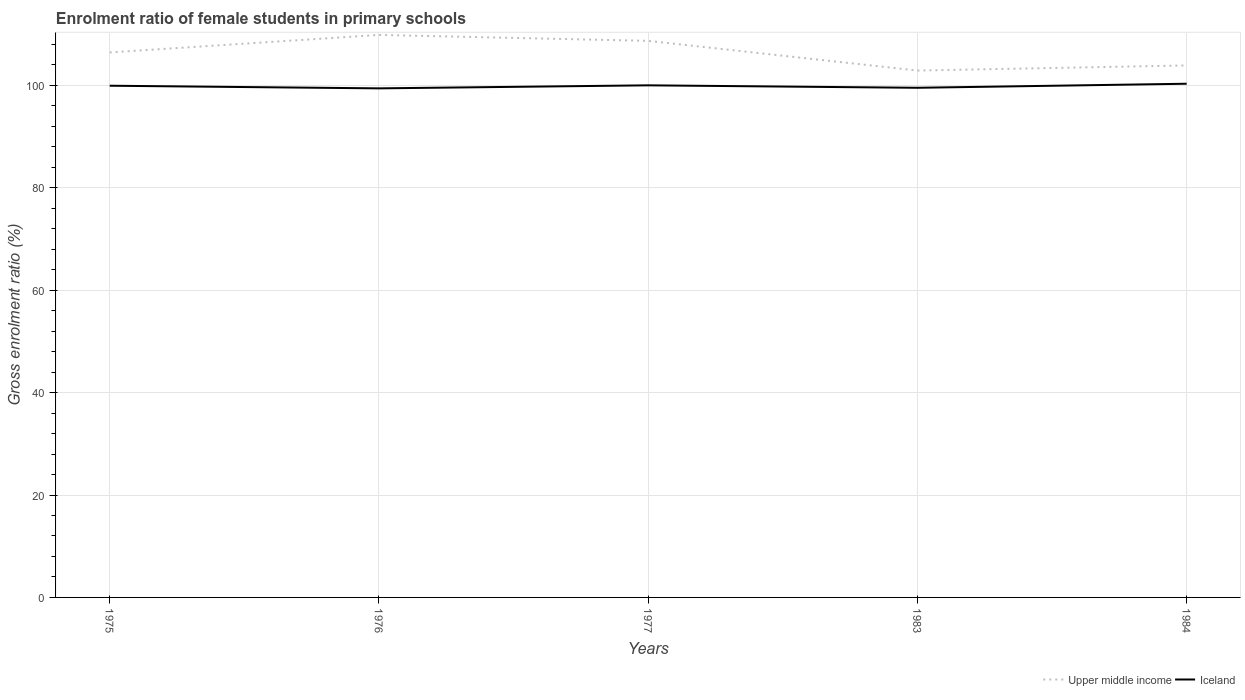How many different coloured lines are there?
Your response must be concise. 2. Does the line corresponding to Iceland intersect with the line corresponding to Upper middle income?
Your answer should be compact. No. Is the number of lines equal to the number of legend labels?
Offer a very short reply. Yes. Across all years, what is the maximum enrolment ratio of female students in primary schools in Upper middle income?
Offer a very short reply. 102.91. In which year was the enrolment ratio of female students in primary schools in Iceland maximum?
Provide a short and direct response. 1976. What is the total enrolment ratio of female students in primary schools in Upper middle income in the graph?
Offer a very short reply. 5.8. What is the difference between the highest and the second highest enrolment ratio of female students in primary schools in Upper middle income?
Your answer should be compact. 6.96. Are the values on the major ticks of Y-axis written in scientific E-notation?
Your answer should be compact. No. What is the title of the graph?
Your answer should be compact. Enrolment ratio of female students in primary schools. What is the label or title of the X-axis?
Make the answer very short. Years. What is the Gross enrolment ratio (%) in Upper middle income in 1975?
Provide a succinct answer. 106.45. What is the Gross enrolment ratio (%) of Iceland in 1975?
Your response must be concise. 99.95. What is the Gross enrolment ratio (%) of Upper middle income in 1976?
Your response must be concise. 109.87. What is the Gross enrolment ratio (%) of Iceland in 1976?
Ensure brevity in your answer.  99.43. What is the Gross enrolment ratio (%) of Upper middle income in 1977?
Ensure brevity in your answer.  108.71. What is the Gross enrolment ratio (%) in Iceland in 1977?
Provide a short and direct response. 100.02. What is the Gross enrolment ratio (%) of Upper middle income in 1983?
Make the answer very short. 102.91. What is the Gross enrolment ratio (%) of Iceland in 1983?
Offer a terse response. 99.54. What is the Gross enrolment ratio (%) of Upper middle income in 1984?
Your answer should be compact. 103.91. What is the Gross enrolment ratio (%) in Iceland in 1984?
Offer a terse response. 100.33. Across all years, what is the maximum Gross enrolment ratio (%) of Upper middle income?
Give a very brief answer. 109.87. Across all years, what is the maximum Gross enrolment ratio (%) in Iceland?
Your response must be concise. 100.33. Across all years, what is the minimum Gross enrolment ratio (%) of Upper middle income?
Make the answer very short. 102.91. Across all years, what is the minimum Gross enrolment ratio (%) in Iceland?
Offer a terse response. 99.43. What is the total Gross enrolment ratio (%) of Upper middle income in the graph?
Offer a very short reply. 531.84. What is the total Gross enrolment ratio (%) in Iceland in the graph?
Your answer should be very brief. 499.28. What is the difference between the Gross enrolment ratio (%) in Upper middle income in 1975 and that in 1976?
Ensure brevity in your answer.  -3.42. What is the difference between the Gross enrolment ratio (%) of Iceland in 1975 and that in 1976?
Offer a very short reply. 0.52. What is the difference between the Gross enrolment ratio (%) of Upper middle income in 1975 and that in 1977?
Give a very brief answer. -2.26. What is the difference between the Gross enrolment ratio (%) of Iceland in 1975 and that in 1977?
Make the answer very short. -0.08. What is the difference between the Gross enrolment ratio (%) in Upper middle income in 1975 and that in 1983?
Your response must be concise. 3.54. What is the difference between the Gross enrolment ratio (%) of Iceland in 1975 and that in 1983?
Ensure brevity in your answer.  0.41. What is the difference between the Gross enrolment ratio (%) of Upper middle income in 1975 and that in 1984?
Give a very brief answer. 2.54. What is the difference between the Gross enrolment ratio (%) of Iceland in 1975 and that in 1984?
Your answer should be very brief. -0.39. What is the difference between the Gross enrolment ratio (%) of Upper middle income in 1976 and that in 1977?
Keep it short and to the point. 1.16. What is the difference between the Gross enrolment ratio (%) of Iceland in 1976 and that in 1977?
Your answer should be very brief. -0.59. What is the difference between the Gross enrolment ratio (%) in Upper middle income in 1976 and that in 1983?
Your response must be concise. 6.96. What is the difference between the Gross enrolment ratio (%) in Iceland in 1976 and that in 1983?
Offer a very short reply. -0.11. What is the difference between the Gross enrolment ratio (%) of Upper middle income in 1976 and that in 1984?
Your answer should be compact. 5.96. What is the difference between the Gross enrolment ratio (%) of Iceland in 1976 and that in 1984?
Offer a very short reply. -0.9. What is the difference between the Gross enrolment ratio (%) of Upper middle income in 1977 and that in 1983?
Your response must be concise. 5.8. What is the difference between the Gross enrolment ratio (%) of Iceland in 1977 and that in 1983?
Your response must be concise. 0.48. What is the difference between the Gross enrolment ratio (%) of Upper middle income in 1977 and that in 1984?
Ensure brevity in your answer.  4.8. What is the difference between the Gross enrolment ratio (%) of Iceland in 1977 and that in 1984?
Ensure brevity in your answer.  -0.31. What is the difference between the Gross enrolment ratio (%) in Upper middle income in 1983 and that in 1984?
Ensure brevity in your answer.  -1. What is the difference between the Gross enrolment ratio (%) of Iceland in 1983 and that in 1984?
Provide a short and direct response. -0.79. What is the difference between the Gross enrolment ratio (%) of Upper middle income in 1975 and the Gross enrolment ratio (%) of Iceland in 1976?
Give a very brief answer. 7.02. What is the difference between the Gross enrolment ratio (%) in Upper middle income in 1975 and the Gross enrolment ratio (%) in Iceland in 1977?
Make the answer very short. 6.43. What is the difference between the Gross enrolment ratio (%) in Upper middle income in 1975 and the Gross enrolment ratio (%) in Iceland in 1983?
Ensure brevity in your answer.  6.91. What is the difference between the Gross enrolment ratio (%) of Upper middle income in 1975 and the Gross enrolment ratio (%) of Iceland in 1984?
Make the answer very short. 6.12. What is the difference between the Gross enrolment ratio (%) in Upper middle income in 1976 and the Gross enrolment ratio (%) in Iceland in 1977?
Provide a short and direct response. 9.84. What is the difference between the Gross enrolment ratio (%) in Upper middle income in 1976 and the Gross enrolment ratio (%) in Iceland in 1983?
Offer a terse response. 10.33. What is the difference between the Gross enrolment ratio (%) in Upper middle income in 1976 and the Gross enrolment ratio (%) in Iceland in 1984?
Provide a short and direct response. 9.53. What is the difference between the Gross enrolment ratio (%) of Upper middle income in 1977 and the Gross enrolment ratio (%) of Iceland in 1983?
Provide a short and direct response. 9.16. What is the difference between the Gross enrolment ratio (%) of Upper middle income in 1977 and the Gross enrolment ratio (%) of Iceland in 1984?
Provide a succinct answer. 8.37. What is the difference between the Gross enrolment ratio (%) of Upper middle income in 1983 and the Gross enrolment ratio (%) of Iceland in 1984?
Your answer should be very brief. 2.57. What is the average Gross enrolment ratio (%) of Upper middle income per year?
Provide a short and direct response. 106.37. What is the average Gross enrolment ratio (%) of Iceland per year?
Provide a short and direct response. 99.86. In the year 1975, what is the difference between the Gross enrolment ratio (%) in Upper middle income and Gross enrolment ratio (%) in Iceland?
Keep it short and to the point. 6.5. In the year 1976, what is the difference between the Gross enrolment ratio (%) of Upper middle income and Gross enrolment ratio (%) of Iceland?
Give a very brief answer. 10.44. In the year 1977, what is the difference between the Gross enrolment ratio (%) in Upper middle income and Gross enrolment ratio (%) in Iceland?
Ensure brevity in your answer.  8.68. In the year 1983, what is the difference between the Gross enrolment ratio (%) of Upper middle income and Gross enrolment ratio (%) of Iceland?
Give a very brief answer. 3.36. In the year 1984, what is the difference between the Gross enrolment ratio (%) of Upper middle income and Gross enrolment ratio (%) of Iceland?
Your answer should be very brief. 3.57. What is the ratio of the Gross enrolment ratio (%) of Upper middle income in 1975 to that in 1976?
Offer a very short reply. 0.97. What is the ratio of the Gross enrolment ratio (%) of Iceland in 1975 to that in 1976?
Keep it short and to the point. 1.01. What is the ratio of the Gross enrolment ratio (%) in Upper middle income in 1975 to that in 1977?
Provide a succinct answer. 0.98. What is the ratio of the Gross enrolment ratio (%) of Iceland in 1975 to that in 1977?
Offer a very short reply. 1. What is the ratio of the Gross enrolment ratio (%) in Upper middle income in 1975 to that in 1983?
Make the answer very short. 1.03. What is the ratio of the Gross enrolment ratio (%) in Iceland in 1975 to that in 1983?
Ensure brevity in your answer.  1. What is the ratio of the Gross enrolment ratio (%) of Upper middle income in 1975 to that in 1984?
Provide a short and direct response. 1.02. What is the ratio of the Gross enrolment ratio (%) of Iceland in 1975 to that in 1984?
Ensure brevity in your answer.  1. What is the ratio of the Gross enrolment ratio (%) of Upper middle income in 1976 to that in 1977?
Provide a succinct answer. 1.01. What is the ratio of the Gross enrolment ratio (%) of Upper middle income in 1976 to that in 1983?
Ensure brevity in your answer.  1.07. What is the ratio of the Gross enrolment ratio (%) in Iceland in 1976 to that in 1983?
Offer a very short reply. 1. What is the ratio of the Gross enrolment ratio (%) in Upper middle income in 1976 to that in 1984?
Offer a terse response. 1.06. What is the ratio of the Gross enrolment ratio (%) in Upper middle income in 1977 to that in 1983?
Make the answer very short. 1.06. What is the ratio of the Gross enrolment ratio (%) of Upper middle income in 1977 to that in 1984?
Your response must be concise. 1.05. What is the ratio of the Gross enrolment ratio (%) in Upper middle income in 1983 to that in 1984?
Offer a very short reply. 0.99. What is the difference between the highest and the second highest Gross enrolment ratio (%) in Upper middle income?
Keep it short and to the point. 1.16. What is the difference between the highest and the second highest Gross enrolment ratio (%) of Iceland?
Provide a succinct answer. 0.31. What is the difference between the highest and the lowest Gross enrolment ratio (%) in Upper middle income?
Ensure brevity in your answer.  6.96. What is the difference between the highest and the lowest Gross enrolment ratio (%) in Iceland?
Your answer should be very brief. 0.9. 